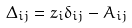<formula> <loc_0><loc_0><loc_500><loc_500>\Delta _ { i j } = z _ { i } \delta _ { i j } - A _ { i j }</formula> 